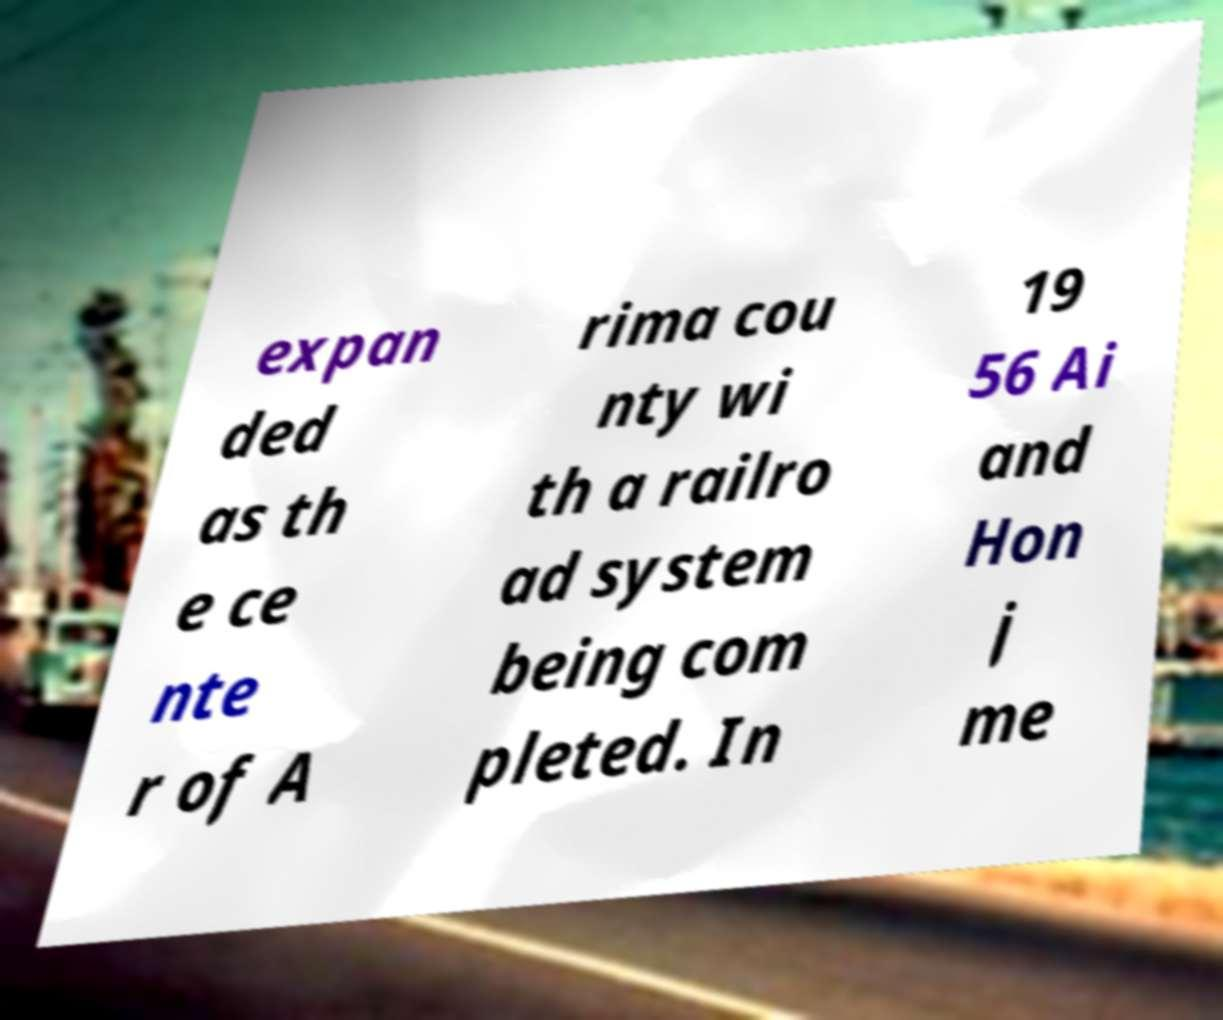Could you assist in decoding the text presented in this image and type it out clearly? expan ded as th e ce nte r of A rima cou nty wi th a railro ad system being com pleted. In 19 56 Ai and Hon j me 